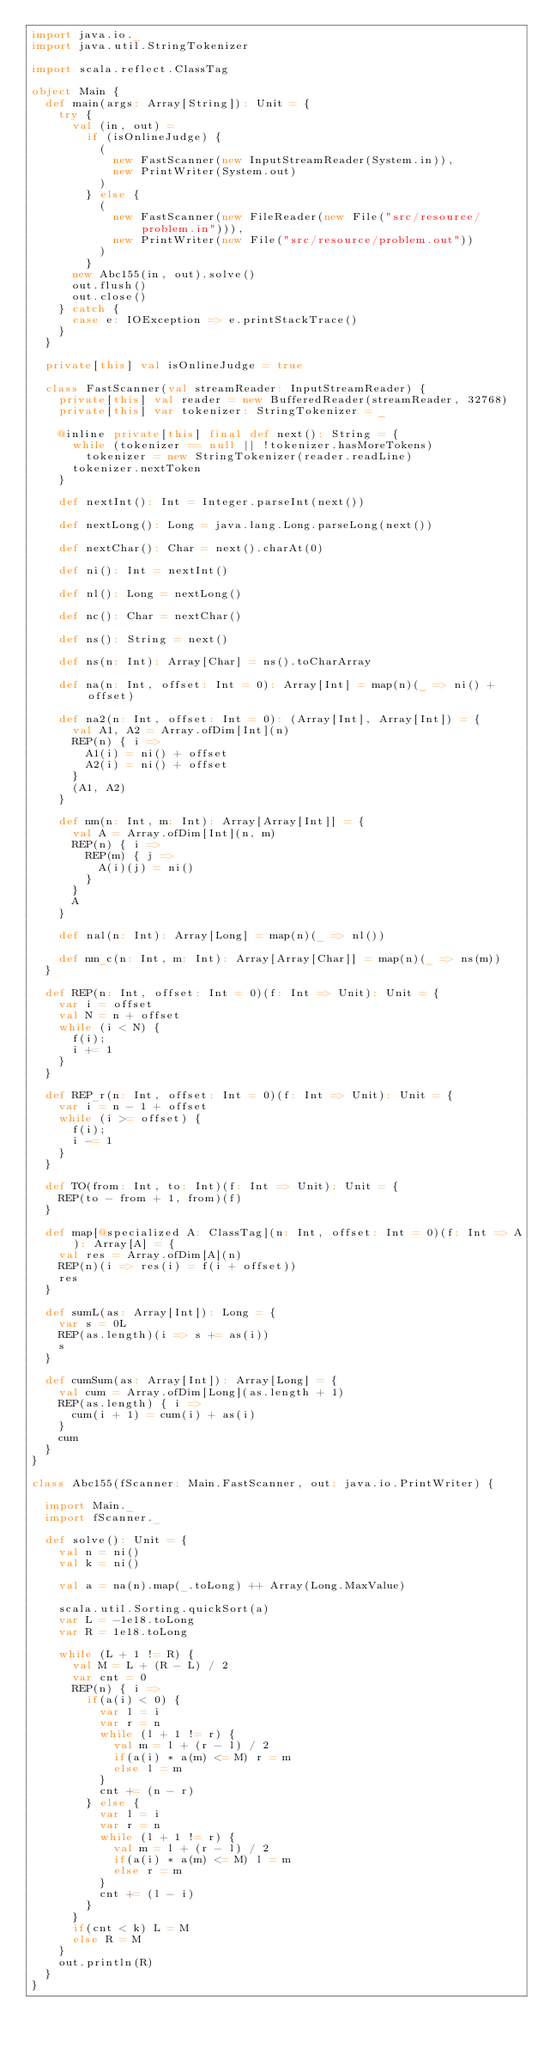Convert code to text. <code><loc_0><loc_0><loc_500><loc_500><_Scala_>import java.io._
import java.util.StringTokenizer

import scala.reflect.ClassTag

object Main {
  def main(args: Array[String]): Unit = {
    try {
      val (in, out) =
        if (isOnlineJudge) {
          (
            new FastScanner(new InputStreamReader(System.in)),
            new PrintWriter(System.out)
          )
        } else {
          (
            new FastScanner(new FileReader(new File("src/resource/problem.in"))),
            new PrintWriter(new File("src/resource/problem.out"))
          )
        }
      new Abc155(in, out).solve()
      out.flush()
      out.close()
    } catch {
      case e: IOException => e.printStackTrace()
    }
  }

  private[this] val isOnlineJudge = true

  class FastScanner(val streamReader: InputStreamReader) {
    private[this] val reader = new BufferedReader(streamReader, 32768)
    private[this] var tokenizer: StringTokenizer = _

    @inline private[this] final def next(): String = {
      while (tokenizer == null || !tokenizer.hasMoreTokens)
        tokenizer = new StringTokenizer(reader.readLine)
      tokenizer.nextToken
    }

    def nextInt(): Int = Integer.parseInt(next())

    def nextLong(): Long = java.lang.Long.parseLong(next())

    def nextChar(): Char = next().charAt(0)

    def ni(): Int = nextInt()

    def nl(): Long = nextLong()

    def nc(): Char = nextChar()

    def ns(): String = next()

    def ns(n: Int): Array[Char] = ns().toCharArray

    def na(n: Int, offset: Int = 0): Array[Int] = map(n)(_ => ni() + offset)

    def na2(n: Int, offset: Int = 0): (Array[Int], Array[Int]) = {
      val A1, A2 = Array.ofDim[Int](n)
      REP(n) { i =>
        A1(i) = ni() + offset
        A2(i) = ni() + offset
      }
      (A1, A2)
    }

    def nm(n: Int, m: Int): Array[Array[Int]] = {
      val A = Array.ofDim[Int](n, m)
      REP(n) { i =>
        REP(m) { j =>
          A(i)(j) = ni()
        }
      }
      A
    }

    def nal(n: Int): Array[Long] = map(n)(_ => nl())

    def nm_c(n: Int, m: Int): Array[Array[Char]] = map(n)(_ => ns(m))
  }

  def REP(n: Int, offset: Int = 0)(f: Int => Unit): Unit = {
    var i = offset
    val N = n + offset
    while (i < N) {
      f(i);
      i += 1
    }
  }

  def REP_r(n: Int, offset: Int = 0)(f: Int => Unit): Unit = {
    var i = n - 1 + offset
    while (i >= offset) {
      f(i);
      i -= 1
    }
  }

  def TO(from: Int, to: Int)(f: Int => Unit): Unit = {
    REP(to - from + 1, from)(f)
  }

  def map[@specialized A: ClassTag](n: Int, offset: Int = 0)(f: Int => A): Array[A] = {
    val res = Array.ofDim[A](n)
    REP(n)(i => res(i) = f(i + offset))
    res
  }

  def sumL(as: Array[Int]): Long = {
    var s = 0L
    REP(as.length)(i => s += as(i))
    s
  }

  def cumSum(as: Array[Int]): Array[Long] = {
    val cum = Array.ofDim[Long](as.length + 1)
    REP(as.length) { i =>
      cum(i + 1) = cum(i) + as(i)
    }
    cum
  }
}

class Abc155(fScanner: Main.FastScanner, out: java.io.PrintWriter) {

  import Main._
  import fScanner._

  def solve(): Unit = {
    val n = ni()
    val k = ni()

    val a = na(n).map(_.toLong) ++ Array(Long.MaxValue)

    scala.util.Sorting.quickSort(a)
    var L = -1e18.toLong
    var R = 1e18.toLong

    while (L + 1 != R) {
      val M = L + (R - L) / 2
      var cnt = 0
      REP(n) { i =>
        if(a(i) < 0) {
          var l = i
          var r = n
          while (l + 1 != r) {
            val m = l + (r - l) / 2
            if(a(i) * a(m) <= M) r = m
            else l = m
          }
          cnt += (n - r)
        } else {
          var l = i
          var r = n
          while (l + 1 != r) {
            val m = l + (r - l) / 2
            if(a(i) * a(m) <= M) l = m
            else r = m
          }
          cnt += (l - i)
        }
      }
      if(cnt < k) L = M
      else R = M
    }
    out.println(R)
  }
}
</code> 